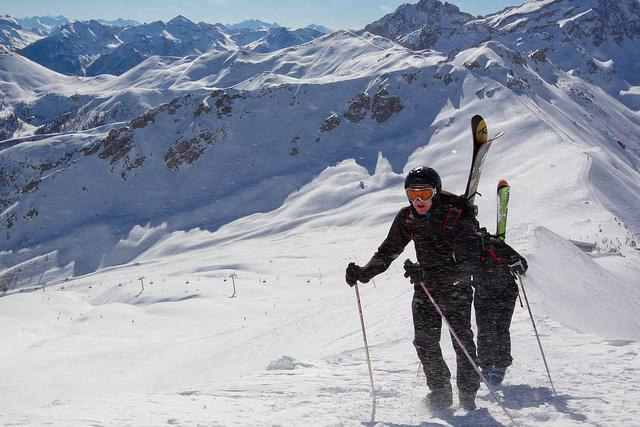What is the primary color of the skis carried on the back of the man following the man? Please explain your reasoning. green. The skis are not yellow, black, or red. 